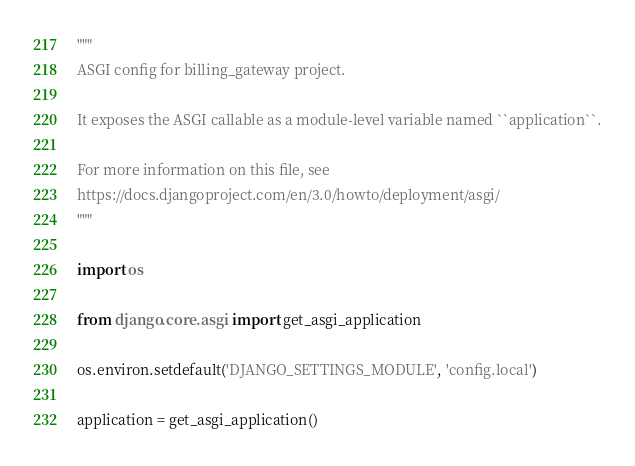<code> <loc_0><loc_0><loc_500><loc_500><_Python_>"""
ASGI config for billing_gateway project.

It exposes the ASGI callable as a module-level variable named ``application``.

For more information on this file, see
https://docs.djangoproject.com/en/3.0/howto/deployment/asgi/
"""

import os

from django.core.asgi import get_asgi_application

os.environ.setdefault('DJANGO_SETTINGS_MODULE', 'config.local')

application = get_asgi_application()
</code> 